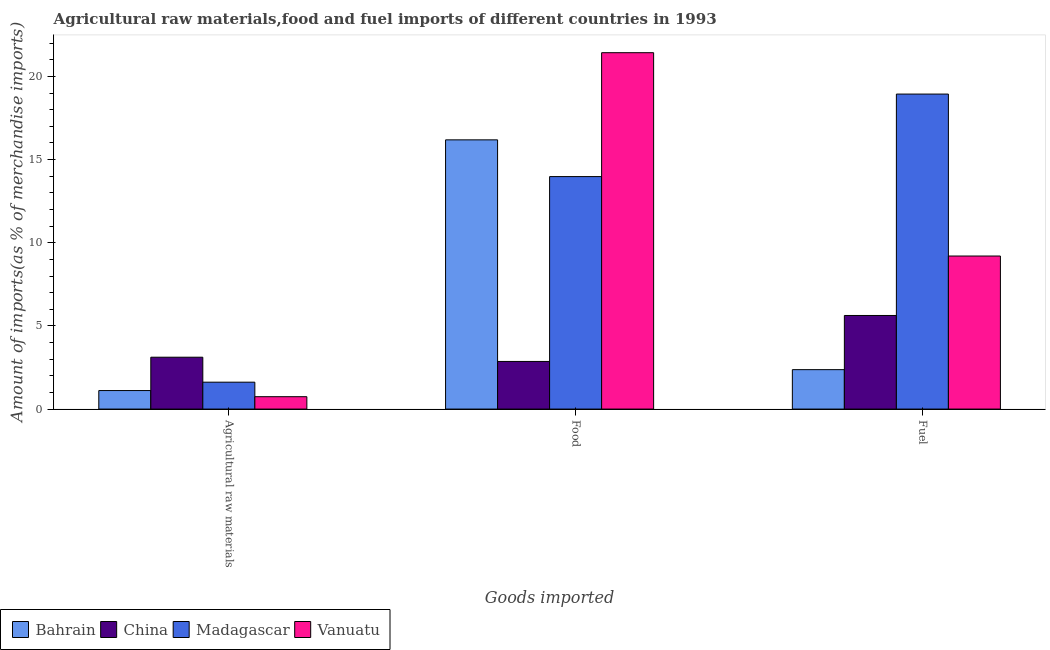How many groups of bars are there?
Offer a terse response. 3. Are the number of bars per tick equal to the number of legend labels?
Ensure brevity in your answer.  Yes. Are the number of bars on each tick of the X-axis equal?
Provide a succinct answer. Yes. How many bars are there on the 3rd tick from the left?
Provide a short and direct response. 4. What is the label of the 3rd group of bars from the left?
Make the answer very short. Fuel. What is the percentage of food imports in Madagascar?
Offer a very short reply. 13.98. Across all countries, what is the maximum percentage of food imports?
Give a very brief answer. 21.43. Across all countries, what is the minimum percentage of food imports?
Offer a very short reply. 2.86. In which country was the percentage of food imports maximum?
Provide a succinct answer. Vanuatu. In which country was the percentage of raw materials imports minimum?
Your answer should be compact. Vanuatu. What is the total percentage of fuel imports in the graph?
Ensure brevity in your answer.  36.14. What is the difference between the percentage of food imports in Bahrain and that in Madagascar?
Provide a succinct answer. 2.21. What is the difference between the percentage of fuel imports in Vanuatu and the percentage of food imports in Bahrain?
Provide a short and direct response. -6.98. What is the average percentage of fuel imports per country?
Keep it short and to the point. 9.03. What is the difference between the percentage of food imports and percentage of raw materials imports in China?
Make the answer very short. -0.25. What is the ratio of the percentage of fuel imports in Madagascar to that in Vanuatu?
Give a very brief answer. 2.06. Is the percentage of raw materials imports in Bahrain less than that in China?
Your response must be concise. Yes. What is the difference between the highest and the second highest percentage of raw materials imports?
Your answer should be very brief. 1.5. What is the difference between the highest and the lowest percentage of food imports?
Provide a succinct answer. 18.56. What does the 2nd bar from the left in Fuel represents?
Your answer should be very brief. China. What does the 1st bar from the right in Fuel represents?
Offer a terse response. Vanuatu. Are all the bars in the graph horizontal?
Make the answer very short. No. How many countries are there in the graph?
Provide a succinct answer. 4. Are the values on the major ticks of Y-axis written in scientific E-notation?
Provide a short and direct response. No. Does the graph contain any zero values?
Keep it short and to the point. No. Does the graph contain grids?
Provide a succinct answer. No. How are the legend labels stacked?
Your answer should be very brief. Horizontal. What is the title of the graph?
Provide a short and direct response. Agricultural raw materials,food and fuel imports of different countries in 1993. Does "Indonesia" appear as one of the legend labels in the graph?
Give a very brief answer. No. What is the label or title of the X-axis?
Your answer should be very brief. Goods imported. What is the label or title of the Y-axis?
Give a very brief answer. Amount of imports(as % of merchandise imports). What is the Amount of imports(as % of merchandise imports) of Bahrain in Agricultural raw materials?
Your response must be concise. 1.11. What is the Amount of imports(as % of merchandise imports) in China in Agricultural raw materials?
Provide a succinct answer. 3.12. What is the Amount of imports(as % of merchandise imports) in Madagascar in Agricultural raw materials?
Ensure brevity in your answer.  1.62. What is the Amount of imports(as % of merchandise imports) of Vanuatu in Agricultural raw materials?
Your response must be concise. 0.74. What is the Amount of imports(as % of merchandise imports) in Bahrain in Food?
Offer a terse response. 16.19. What is the Amount of imports(as % of merchandise imports) of China in Food?
Your response must be concise. 2.86. What is the Amount of imports(as % of merchandise imports) of Madagascar in Food?
Keep it short and to the point. 13.98. What is the Amount of imports(as % of merchandise imports) of Vanuatu in Food?
Offer a very short reply. 21.43. What is the Amount of imports(as % of merchandise imports) in Bahrain in Fuel?
Your answer should be very brief. 2.37. What is the Amount of imports(as % of merchandise imports) in China in Fuel?
Offer a terse response. 5.63. What is the Amount of imports(as % of merchandise imports) of Madagascar in Fuel?
Your response must be concise. 18.94. What is the Amount of imports(as % of merchandise imports) in Vanuatu in Fuel?
Keep it short and to the point. 9.2. Across all Goods imported, what is the maximum Amount of imports(as % of merchandise imports) in Bahrain?
Offer a terse response. 16.19. Across all Goods imported, what is the maximum Amount of imports(as % of merchandise imports) of China?
Provide a short and direct response. 5.63. Across all Goods imported, what is the maximum Amount of imports(as % of merchandise imports) in Madagascar?
Offer a terse response. 18.94. Across all Goods imported, what is the maximum Amount of imports(as % of merchandise imports) in Vanuatu?
Make the answer very short. 21.43. Across all Goods imported, what is the minimum Amount of imports(as % of merchandise imports) of Bahrain?
Make the answer very short. 1.11. Across all Goods imported, what is the minimum Amount of imports(as % of merchandise imports) in China?
Provide a short and direct response. 2.86. Across all Goods imported, what is the minimum Amount of imports(as % of merchandise imports) of Madagascar?
Your answer should be compact. 1.62. Across all Goods imported, what is the minimum Amount of imports(as % of merchandise imports) in Vanuatu?
Your response must be concise. 0.74. What is the total Amount of imports(as % of merchandise imports) of Bahrain in the graph?
Your answer should be very brief. 19.67. What is the total Amount of imports(as % of merchandise imports) in China in the graph?
Offer a very short reply. 11.61. What is the total Amount of imports(as % of merchandise imports) in Madagascar in the graph?
Your response must be concise. 34.53. What is the total Amount of imports(as % of merchandise imports) in Vanuatu in the graph?
Offer a very short reply. 31.37. What is the difference between the Amount of imports(as % of merchandise imports) in Bahrain in Agricultural raw materials and that in Food?
Ensure brevity in your answer.  -15.07. What is the difference between the Amount of imports(as % of merchandise imports) in China in Agricultural raw materials and that in Food?
Keep it short and to the point. 0.25. What is the difference between the Amount of imports(as % of merchandise imports) in Madagascar in Agricultural raw materials and that in Food?
Offer a terse response. -12.36. What is the difference between the Amount of imports(as % of merchandise imports) of Vanuatu in Agricultural raw materials and that in Food?
Make the answer very short. -20.68. What is the difference between the Amount of imports(as % of merchandise imports) of Bahrain in Agricultural raw materials and that in Fuel?
Your response must be concise. -1.26. What is the difference between the Amount of imports(as % of merchandise imports) of China in Agricultural raw materials and that in Fuel?
Ensure brevity in your answer.  -2.51. What is the difference between the Amount of imports(as % of merchandise imports) in Madagascar in Agricultural raw materials and that in Fuel?
Keep it short and to the point. -17.32. What is the difference between the Amount of imports(as % of merchandise imports) of Vanuatu in Agricultural raw materials and that in Fuel?
Give a very brief answer. -8.46. What is the difference between the Amount of imports(as % of merchandise imports) of Bahrain in Food and that in Fuel?
Provide a succinct answer. 13.82. What is the difference between the Amount of imports(as % of merchandise imports) of China in Food and that in Fuel?
Provide a short and direct response. -2.76. What is the difference between the Amount of imports(as % of merchandise imports) in Madagascar in Food and that in Fuel?
Give a very brief answer. -4.96. What is the difference between the Amount of imports(as % of merchandise imports) of Vanuatu in Food and that in Fuel?
Provide a short and direct response. 12.22. What is the difference between the Amount of imports(as % of merchandise imports) of Bahrain in Agricultural raw materials and the Amount of imports(as % of merchandise imports) of China in Food?
Ensure brevity in your answer.  -1.75. What is the difference between the Amount of imports(as % of merchandise imports) in Bahrain in Agricultural raw materials and the Amount of imports(as % of merchandise imports) in Madagascar in Food?
Your answer should be very brief. -12.86. What is the difference between the Amount of imports(as % of merchandise imports) of Bahrain in Agricultural raw materials and the Amount of imports(as % of merchandise imports) of Vanuatu in Food?
Make the answer very short. -20.31. What is the difference between the Amount of imports(as % of merchandise imports) in China in Agricultural raw materials and the Amount of imports(as % of merchandise imports) in Madagascar in Food?
Offer a very short reply. -10.86. What is the difference between the Amount of imports(as % of merchandise imports) in China in Agricultural raw materials and the Amount of imports(as % of merchandise imports) in Vanuatu in Food?
Your answer should be compact. -18.31. What is the difference between the Amount of imports(as % of merchandise imports) of Madagascar in Agricultural raw materials and the Amount of imports(as % of merchandise imports) of Vanuatu in Food?
Offer a terse response. -19.81. What is the difference between the Amount of imports(as % of merchandise imports) in Bahrain in Agricultural raw materials and the Amount of imports(as % of merchandise imports) in China in Fuel?
Offer a very short reply. -4.51. What is the difference between the Amount of imports(as % of merchandise imports) of Bahrain in Agricultural raw materials and the Amount of imports(as % of merchandise imports) of Madagascar in Fuel?
Provide a succinct answer. -17.83. What is the difference between the Amount of imports(as % of merchandise imports) of Bahrain in Agricultural raw materials and the Amount of imports(as % of merchandise imports) of Vanuatu in Fuel?
Your answer should be compact. -8.09. What is the difference between the Amount of imports(as % of merchandise imports) in China in Agricultural raw materials and the Amount of imports(as % of merchandise imports) in Madagascar in Fuel?
Ensure brevity in your answer.  -15.82. What is the difference between the Amount of imports(as % of merchandise imports) in China in Agricultural raw materials and the Amount of imports(as % of merchandise imports) in Vanuatu in Fuel?
Your answer should be very brief. -6.08. What is the difference between the Amount of imports(as % of merchandise imports) in Madagascar in Agricultural raw materials and the Amount of imports(as % of merchandise imports) in Vanuatu in Fuel?
Provide a short and direct response. -7.59. What is the difference between the Amount of imports(as % of merchandise imports) in Bahrain in Food and the Amount of imports(as % of merchandise imports) in China in Fuel?
Ensure brevity in your answer.  10.56. What is the difference between the Amount of imports(as % of merchandise imports) of Bahrain in Food and the Amount of imports(as % of merchandise imports) of Madagascar in Fuel?
Provide a succinct answer. -2.75. What is the difference between the Amount of imports(as % of merchandise imports) in Bahrain in Food and the Amount of imports(as % of merchandise imports) in Vanuatu in Fuel?
Ensure brevity in your answer.  6.98. What is the difference between the Amount of imports(as % of merchandise imports) in China in Food and the Amount of imports(as % of merchandise imports) in Madagascar in Fuel?
Provide a short and direct response. -16.08. What is the difference between the Amount of imports(as % of merchandise imports) of China in Food and the Amount of imports(as % of merchandise imports) of Vanuatu in Fuel?
Offer a terse response. -6.34. What is the difference between the Amount of imports(as % of merchandise imports) of Madagascar in Food and the Amount of imports(as % of merchandise imports) of Vanuatu in Fuel?
Offer a terse response. 4.78. What is the average Amount of imports(as % of merchandise imports) in Bahrain per Goods imported?
Your answer should be compact. 6.56. What is the average Amount of imports(as % of merchandise imports) in China per Goods imported?
Offer a terse response. 3.87. What is the average Amount of imports(as % of merchandise imports) of Madagascar per Goods imported?
Ensure brevity in your answer.  11.51. What is the average Amount of imports(as % of merchandise imports) in Vanuatu per Goods imported?
Offer a very short reply. 10.46. What is the difference between the Amount of imports(as % of merchandise imports) in Bahrain and Amount of imports(as % of merchandise imports) in China in Agricultural raw materials?
Give a very brief answer. -2. What is the difference between the Amount of imports(as % of merchandise imports) in Bahrain and Amount of imports(as % of merchandise imports) in Madagascar in Agricultural raw materials?
Offer a terse response. -0.5. What is the difference between the Amount of imports(as % of merchandise imports) of Bahrain and Amount of imports(as % of merchandise imports) of Vanuatu in Agricultural raw materials?
Your response must be concise. 0.37. What is the difference between the Amount of imports(as % of merchandise imports) in China and Amount of imports(as % of merchandise imports) in Madagascar in Agricultural raw materials?
Keep it short and to the point. 1.5. What is the difference between the Amount of imports(as % of merchandise imports) in China and Amount of imports(as % of merchandise imports) in Vanuatu in Agricultural raw materials?
Your answer should be very brief. 2.37. What is the difference between the Amount of imports(as % of merchandise imports) of Madagascar and Amount of imports(as % of merchandise imports) of Vanuatu in Agricultural raw materials?
Ensure brevity in your answer.  0.87. What is the difference between the Amount of imports(as % of merchandise imports) of Bahrain and Amount of imports(as % of merchandise imports) of China in Food?
Your answer should be compact. 13.32. What is the difference between the Amount of imports(as % of merchandise imports) in Bahrain and Amount of imports(as % of merchandise imports) in Madagascar in Food?
Offer a terse response. 2.21. What is the difference between the Amount of imports(as % of merchandise imports) in Bahrain and Amount of imports(as % of merchandise imports) in Vanuatu in Food?
Keep it short and to the point. -5.24. What is the difference between the Amount of imports(as % of merchandise imports) in China and Amount of imports(as % of merchandise imports) in Madagascar in Food?
Offer a very short reply. -11.12. What is the difference between the Amount of imports(as % of merchandise imports) of China and Amount of imports(as % of merchandise imports) of Vanuatu in Food?
Your answer should be compact. -18.56. What is the difference between the Amount of imports(as % of merchandise imports) in Madagascar and Amount of imports(as % of merchandise imports) in Vanuatu in Food?
Ensure brevity in your answer.  -7.45. What is the difference between the Amount of imports(as % of merchandise imports) in Bahrain and Amount of imports(as % of merchandise imports) in China in Fuel?
Your answer should be very brief. -3.26. What is the difference between the Amount of imports(as % of merchandise imports) in Bahrain and Amount of imports(as % of merchandise imports) in Madagascar in Fuel?
Offer a very short reply. -16.57. What is the difference between the Amount of imports(as % of merchandise imports) of Bahrain and Amount of imports(as % of merchandise imports) of Vanuatu in Fuel?
Ensure brevity in your answer.  -6.83. What is the difference between the Amount of imports(as % of merchandise imports) in China and Amount of imports(as % of merchandise imports) in Madagascar in Fuel?
Your answer should be very brief. -13.31. What is the difference between the Amount of imports(as % of merchandise imports) of China and Amount of imports(as % of merchandise imports) of Vanuatu in Fuel?
Offer a terse response. -3.57. What is the difference between the Amount of imports(as % of merchandise imports) in Madagascar and Amount of imports(as % of merchandise imports) in Vanuatu in Fuel?
Your answer should be very brief. 9.74. What is the ratio of the Amount of imports(as % of merchandise imports) in Bahrain in Agricultural raw materials to that in Food?
Keep it short and to the point. 0.07. What is the ratio of the Amount of imports(as % of merchandise imports) of China in Agricultural raw materials to that in Food?
Your answer should be very brief. 1.09. What is the ratio of the Amount of imports(as % of merchandise imports) in Madagascar in Agricultural raw materials to that in Food?
Make the answer very short. 0.12. What is the ratio of the Amount of imports(as % of merchandise imports) in Vanuatu in Agricultural raw materials to that in Food?
Your answer should be compact. 0.03. What is the ratio of the Amount of imports(as % of merchandise imports) in Bahrain in Agricultural raw materials to that in Fuel?
Your answer should be very brief. 0.47. What is the ratio of the Amount of imports(as % of merchandise imports) of China in Agricultural raw materials to that in Fuel?
Give a very brief answer. 0.55. What is the ratio of the Amount of imports(as % of merchandise imports) of Madagascar in Agricultural raw materials to that in Fuel?
Make the answer very short. 0.09. What is the ratio of the Amount of imports(as % of merchandise imports) of Vanuatu in Agricultural raw materials to that in Fuel?
Your response must be concise. 0.08. What is the ratio of the Amount of imports(as % of merchandise imports) in Bahrain in Food to that in Fuel?
Your answer should be compact. 6.83. What is the ratio of the Amount of imports(as % of merchandise imports) in China in Food to that in Fuel?
Give a very brief answer. 0.51. What is the ratio of the Amount of imports(as % of merchandise imports) of Madagascar in Food to that in Fuel?
Provide a short and direct response. 0.74. What is the ratio of the Amount of imports(as % of merchandise imports) in Vanuatu in Food to that in Fuel?
Keep it short and to the point. 2.33. What is the difference between the highest and the second highest Amount of imports(as % of merchandise imports) in Bahrain?
Provide a short and direct response. 13.82. What is the difference between the highest and the second highest Amount of imports(as % of merchandise imports) in China?
Give a very brief answer. 2.51. What is the difference between the highest and the second highest Amount of imports(as % of merchandise imports) in Madagascar?
Offer a terse response. 4.96. What is the difference between the highest and the second highest Amount of imports(as % of merchandise imports) in Vanuatu?
Offer a very short reply. 12.22. What is the difference between the highest and the lowest Amount of imports(as % of merchandise imports) in Bahrain?
Provide a succinct answer. 15.07. What is the difference between the highest and the lowest Amount of imports(as % of merchandise imports) of China?
Your answer should be very brief. 2.76. What is the difference between the highest and the lowest Amount of imports(as % of merchandise imports) in Madagascar?
Offer a very short reply. 17.32. What is the difference between the highest and the lowest Amount of imports(as % of merchandise imports) of Vanuatu?
Your response must be concise. 20.68. 